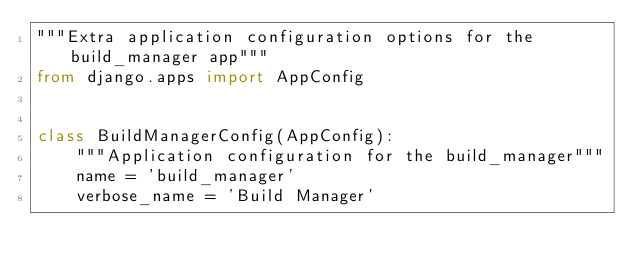Convert code to text. <code><loc_0><loc_0><loc_500><loc_500><_Python_>"""Extra application configuration options for the build_manager app"""
from django.apps import AppConfig


class BuildManagerConfig(AppConfig):
    """Application configuration for the build_manager"""
    name = 'build_manager'
    verbose_name = 'Build Manager'
</code> 